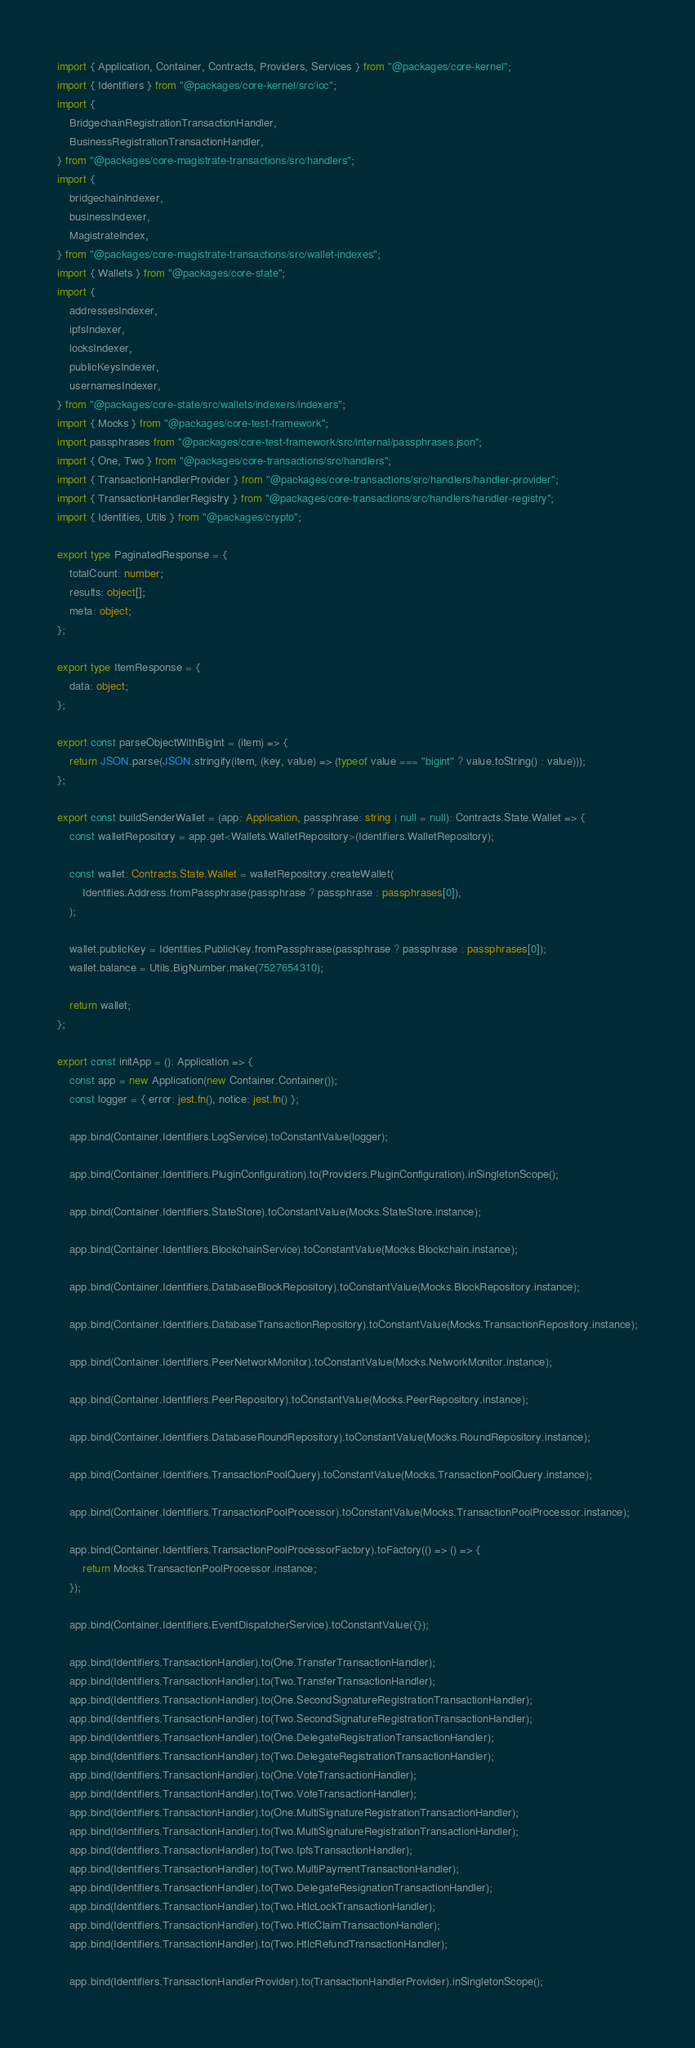<code> <loc_0><loc_0><loc_500><loc_500><_TypeScript_>import { Application, Container, Contracts, Providers, Services } from "@packages/core-kernel";
import { Identifiers } from "@packages/core-kernel/src/ioc";
import {
    BridgechainRegistrationTransactionHandler,
    BusinessRegistrationTransactionHandler,
} from "@packages/core-magistrate-transactions/src/handlers";
import {
    bridgechainIndexer,
    businessIndexer,
    MagistrateIndex,
} from "@packages/core-magistrate-transactions/src/wallet-indexes";
import { Wallets } from "@packages/core-state";
import {
    addressesIndexer,
    ipfsIndexer,
    locksIndexer,
    publicKeysIndexer,
    usernamesIndexer,
} from "@packages/core-state/src/wallets/indexers/indexers";
import { Mocks } from "@packages/core-test-framework";
import passphrases from "@packages/core-test-framework/src/internal/passphrases.json";
import { One, Two } from "@packages/core-transactions/src/handlers";
import { TransactionHandlerProvider } from "@packages/core-transactions/src/handlers/handler-provider";
import { TransactionHandlerRegistry } from "@packages/core-transactions/src/handlers/handler-registry";
import { Identities, Utils } from "@packages/crypto";

export type PaginatedResponse = {
    totalCount: number;
    results: object[];
    meta: object;
};

export type ItemResponse = {
    data: object;
};

export const parseObjectWithBigInt = (item) => {
    return JSON.parse(JSON.stringify(item, (key, value) => (typeof value === "bigint" ? value.toString() : value)));
};

export const buildSenderWallet = (app: Application, passphrase: string | null = null): Contracts.State.Wallet => {
    const walletRepository = app.get<Wallets.WalletRepository>(Identifiers.WalletRepository);

    const wallet: Contracts.State.Wallet = walletRepository.createWallet(
        Identities.Address.fromPassphrase(passphrase ? passphrase : passphrases[0]),
    );

    wallet.publicKey = Identities.PublicKey.fromPassphrase(passphrase ? passphrase : passphrases[0]);
    wallet.balance = Utils.BigNumber.make(7527654310);

    return wallet;
};

export const initApp = (): Application => {
    const app = new Application(new Container.Container());
    const logger = { error: jest.fn(), notice: jest.fn() };

    app.bind(Container.Identifiers.LogService).toConstantValue(logger);

    app.bind(Container.Identifiers.PluginConfiguration).to(Providers.PluginConfiguration).inSingletonScope();

    app.bind(Container.Identifiers.StateStore).toConstantValue(Mocks.StateStore.instance);

    app.bind(Container.Identifiers.BlockchainService).toConstantValue(Mocks.Blockchain.instance);

    app.bind(Container.Identifiers.DatabaseBlockRepository).toConstantValue(Mocks.BlockRepository.instance);

    app.bind(Container.Identifiers.DatabaseTransactionRepository).toConstantValue(Mocks.TransactionRepository.instance);

    app.bind(Container.Identifiers.PeerNetworkMonitor).toConstantValue(Mocks.NetworkMonitor.instance);

    app.bind(Container.Identifiers.PeerRepository).toConstantValue(Mocks.PeerRepository.instance);

    app.bind(Container.Identifiers.DatabaseRoundRepository).toConstantValue(Mocks.RoundRepository.instance);

    app.bind(Container.Identifiers.TransactionPoolQuery).toConstantValue(Mocks.TransactionPoolQuery.instance);

    app.bind(Container.Identifiers.TransactionPoolProcessor).toConstantValue(Mocks.TransactionPoolProcessor.instance);

    app.bind(Container.Identifiers.TransactionPoolProcessorFactory).toFactory(() => () => {
        return Mocks.TransactionPoolProcessor.instance;
    });

    app.bind(Container.Identifiers.EventDispatcherService).toConstantValue({});

    app.bind(Identifiers.TransactionHandler).to(One.TransferTransactionHandler);
    app.bind(Identifiers.TransactionHandler).to(Two.TransferTransactionHandler);
    app.bind(Identifiers.TransactionHandler).to(One.SecondSignatureRegistrationTransactionHandler);
    app.bind(Identifiers.TransactionHandler).to(Two.SecondSignatureRegistrationTransactionHandler);
    app.bind(Identifiers.TransactionHandler).to(One.DelegateRegistrationTransactionHandler);
    app.bind(Identifiers.TransactionHandler).to(Two.DelegateRegistrationTransactionHandler);
    app.bind(Identifiers.TransactionHandler).to(One.VoteTransactionHandler);
    app.bind(Identifiers.TransactionHandler).to(Two.VoteTransactionHandler);
    app.bind(Identifiers.TransactionHandler).to(One.MultiSignatureRegistrationTransactionHandler);
    app.bind(Identifiers.TransactionHandler).to(Two.MultiSignatureRegistrationTransactionHandler);
    app.bind(Identifiers.TransactionHandler).to(Two.IpfsTransactionHandler);
    app.bind(Identifiers.TransactionHandler).to(Two.MultiPaymentTransactionHandler);
    app.bind(Identifiers.TransactionHandler).to(Two.DelegateResignationTransactionHandler);
    app.bind(Identifiers.TransactionHandler).to(Two.HtlcLockTransactionHandler);
    app.bind(Identifiers.TransactionHandler).to(Two.HtlcClaimTransactionHandler);
    app.bind(Identifiers.TransactionHandler).to(Two.HtlcRefundTransactionHandler);

    app.bind(Identifiers.TransactionHandlerProvider).to(TransactionHandlerProvider).inSingletonScope();</code> 